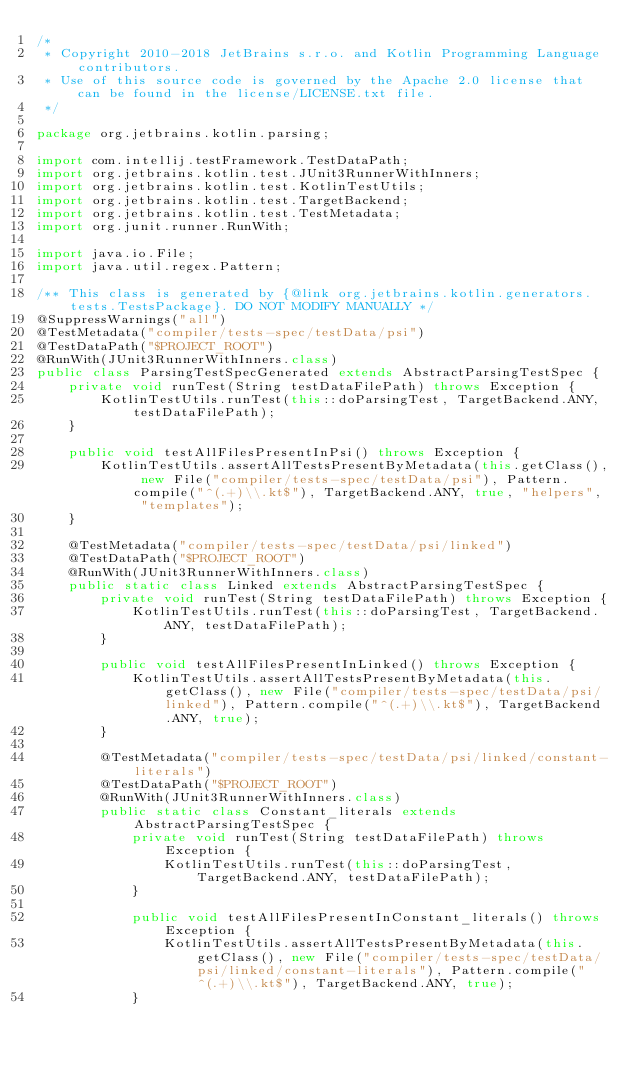Convert code to text. <code><loc_0><loc_0><loc_500><loc_500><_Java_>/*
 * Copyright 2010-2018 JetBrains s.r.o. and Kotlin Programming Language contributors.
 * Use of this source code is governed by the Apache 2.0 license that can be found in the license/LICENSE.txt file.
 */

package org.jetbrains.kotlin.parsing;

import com.intellij.testFramework.TestDataPath;
import org.jetbrains.kotlin.test.JUnit3RunnerWithInners;
import org.jetbrains.kotlin.test.KotlinTestUtils;
import org.jetbrains.kotlin.test.TargetBackend;
import org.jetbrains.kotlin.test.TestMetadata;
import org.junit.runner.RunWith;

import java.io.File;
import java.util.regex.Pattern;

/** This class is generated by {@link org.jetbrains.kotlin.generators.tests.TestsPackage}. DO NOT MODIFY MANUALLY */
@SuppressWarnings("all")
@TestMetadata("compiler/tests-spec/testData/psi")
@TestDataPath("$PROJECT_ROOT")
@RunWith(JUnit3RunnerWithInners.class)
public class ParsingTestSpecGenerated extends AbstractParsingTestSpec {
    private void runTest(String testDataFilePath) throws Exception {
        KotlinTestUtils.runTest(this::doParsingTest, TargetBackend.ANY, testDataFilePath);
    }

    public void testAllFilesPresentInPsi() throws Exception {
        KotlinTestUtils.assertAllTestsPresentByMetadata(this.getClass(), new File("compiler/tests-spec/testData/psi"), Pattern.compile("^(.+)\\.kt$"), TargetBackend.ANY, true, "helpers", "templates");
    }

    @TestMetadata("compiler/tests-spec/testData/psi/linked")
    @TestDataPath("$PROJECT_ROOT")
    @RunWith(JUnit3RunnerWithInners.class)
    public static class Linked extends AbstractParsingTestSpec {
        private void runTest(String testDataFilePath) throws Exception {
            KotlinTestUtils.runTest(this::doParsingTest, TargetBackend.ANY, testDataFilePath);
        }

        public void testAllFilesPresentInLinked() throws Exception {
            KotlinTestUtils.assertAllTestsPresentByMetadata(this.getClass(), new File("compiler/tests-spec/testData/psi/linked"), Pattern.compile("^(.+)\\.kt$"), TargetBackend.ANY, true);
        }

        @TestMetadata("compiler/tests-spec/testData/psi/linked/constant-literals")
        @TestDataPath("$PROJECT_ROOT")
        @RunWith(JUnit3RunnerWithInners.class)
        public static class Constant_literals extends AbstractParsingTestSpec {
            private void runTest(String testDataFilePath) throws Exception {
                KotlinTestUtils.runTest(this::doParsingTest, TargetBackend.ANY, testDataFilePath);
            }

            public void testAllFilesPresentInConstant_literals() throws Exception {
                KotlinTestUtils.assertAllTestsPresentByMetadata(this.getClass(), new File("compiler/tests-spec/testData/psi/linked/constant-literals"), Pattern.compile("^(.+)\\.kt$"), TargetBackend.ANY, true);
            }
</code> 